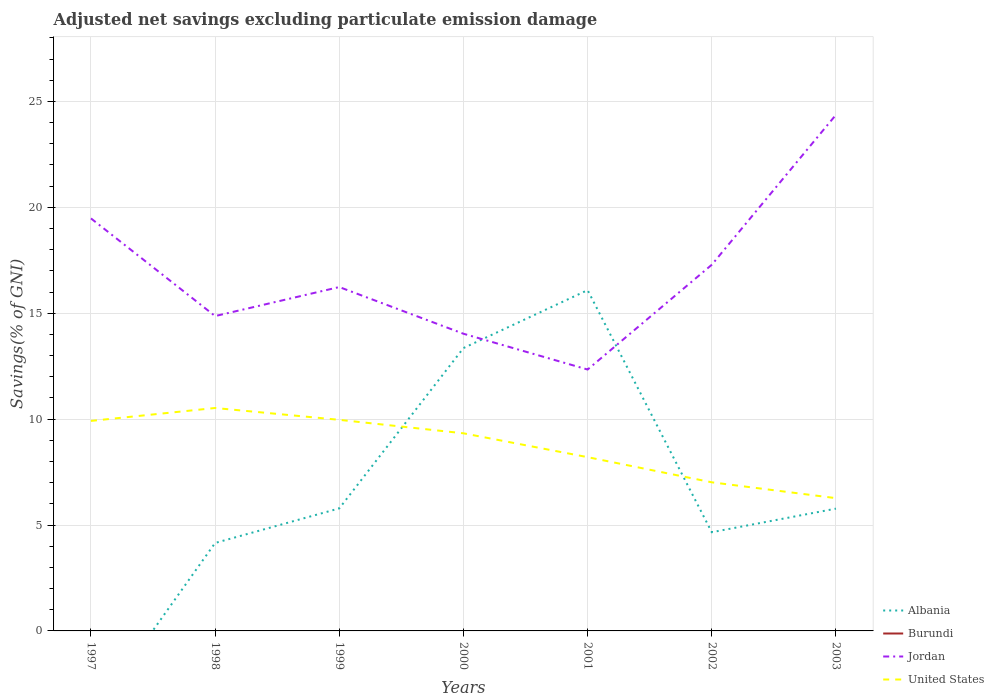Does the line corresponding to Albania intersect with the line corresponding to Burundi?
Your answer should be very brief. No. Is the number of lines equal to the number of legend labels?
Ensure brevity in your answer.  No. Across all years, what is the maximum adjusted net savings in Jordan?
Your response must be concise. 12.34. What is the total adjusted net savings in Jordan in the graph?
Offer a terse response. 2.52. What is the difference between the highest and the second highest adjusted net savings in United States?
Offer a very short reply. 4.26. What is the difference between the highest and the lowest adjusted net savings in Jordan?
Offer a very short reply. 3. How many years are there in the graph?
Keep it short and to the point. 7. What is the difference between two consecutive major ticks on the Y-axis?
Make the answer very short. 5. Where does the legend appear in the graph?
Make the answer very short. Bottom right. How many legend labels are there?
Provide a succinct answer. 4. What is the title of the graph?
Your answer should be very brief. Adjusted net savings excluding particulate emission damage. What is the label or title of the Y-axis?
Your answer should be very brief. Savings(% of GNI). What is the Savings(% of GNI) in Albania in 1997?
Offer a very short reply. 0. What is the Savings(% of GNI) of Burundi in 1997?
Give a very brief answer. 0. What is the Savings(% of GNI) in Jordan in 1997?
Make the answer very short. 19.48. What is the Savings(% of GNI) in United States in 1997?
Your answer should be compact. 9.92. What is the Savings(% of GNI) of Albania in 1998?
Your response must be concise. 4.15. What is the Savings(% of GNI) of Jordan in 1998?
Ensure brevity in your answer.  14.86. What is the Savings(% of GNI) in United States in 1998?
Make the answer very short. 10.53. What is the Savings(% of GNI) in Albania in 1999?
Your answer should be very brief. 5.79. What is the Savings(% of GNI) in Jordan in 1999?
Provide a succinct answer. 16.24. What is the Savings(% of GNI) in United States in 1999?
Offer a very short reply. 9.97. What is the Savings(% of GNI) in Albania in 2000?
Provide a short and direct response. 13.35. What is the Savings(% of GNI) of Jordan in 2000?
Give a very brief answer. 14.03. What is the Savings(% of GNI) in United States in 2000?
Your response must be concise. 9.33. What is the Savings(% of GNI) in Albania in 2001?
Offer a very short reply. 16.09. What is the Savings(% of GNI) in Burundi in 2001?
Offer a terse response. 0. What is the Savings(% of GNI) in Jordan in 2001?
Provide a short and direct response. 12.34. What is the Savings(% of GNI) of United States in 2001?
Make the answer very short. 8.2. What is the Savings(% of GNI) in Albania in 2002?
Your response must be concise. 4.66. What is the Savings(% of GNI) in Jordan in 2002?
Your answer should be compact. 17.29. What is the Savings(% of GNI) of United States in 2002?
Keep it short and to the point. 7.02. What is the Savings(% of GNI) in Albania in 2003?
Provide a short and direct response. 5.77. What is the Savings(% of GNI) of Burundi in 2003?
Ensure brevity in your answer.  0. What is the Savings(% of GNI) in Jordan in 2003?
Your answer should be very brief. 24.37. What is the Savings(% of GNI) of United States in 2003?
Your answer should be compact. 6.27. Across all years, what is the maximum Savings(% of GNI) in Albania?
Ensure brevity in your answer.  16.09. Across all years, what is the maximum Savings(% of GNI) in Jordan?
Offer a very short reply. 24.37. Across all years, what is the maximum Savings(% of GNI) in United States?
Ensure brevity in your answer.  10.53. Across all years, what is the minimum Savings(% of GNI) of Jordan?
Your answer should be compact. 12.34. Across all years, what is the minimum Savings(% of GNI) of United States?
Your answer should be compact. 6.27. What is the total Savings(% of GNI) of Albania in the graph?
Give a very brief answer. 49.82. What is the total Savings(% of GNI) in Burundi in the graph?
Provide a short and direct response. 0. What is the total Savings(% of GNI) of Jordan in the graph?
Provide a succinct answer. 118.6. What is the total Savings(% of GNI) of United States in the graph?
Make the answer very short. 61.23. What is the difference between the Savings(% of GNI) of Jordan in 1997 and that in 1998?
Give a very brief answer. 4.61. What is the difference between the Savings(% of GNI) in United States in 1997 and that in 1998?
Give a very brief answer. -0.61. What is the difference between the Savings(% of GNI) in Jordan in 1997 and that in 1999?
Offer a very short reply. 3.24. What is the difference between the Savings(% of GNI) in United States in 1997 and that in 1999?
Provide a succinct answer. -0.05. What is the difference between the Savings(% of GNI) of Jordan in 1997 and that in 2000?
Your response must be concise. 5.44. What is the difference between the Savings(% of GNI) of United States in 1997 and that in 2000?
Offer a very short reply. 0.59. What is the difference between the Savings(% of GNI) of Jordan in 1997 and that in 2001?
Keep it short and to the point. 7.13. What is the difference between the Savings(% of GNI) in United States in 1997 and that in 2001?
Your response must be concise. 1.71. What is the difference between the Savings(% of GNI) in Jordan in 1997 and that in 2002?
Offer a terse response. 2.19. What is the difference between the Savings(% of GNI) of United States in 1997 and that in 2002?
Provide a short and direct response. 2.9. What is the difference between the Savings(% of GNI) of Jordan in 1997 and that in 2003?
Your answer should be compact. -4.89. What is the difference between the Savings(% of GNI) of United States in 1997 and that in 2003?
Make the answer very short. 3.65. What is the difference between the Savings(% of GNI) in Albania in 1998 and that in 1999?
Your answer should be very brief. -1.63. What is the difference between the Savings(% of GNI) in Jordan in 1998 and that in 1999?
Provide a short and direct response. -1.37. What is the difference between the Savings(% of GNI) in United States in 1998 and that in 1999?
Make the answer very short. 0.56. What is the difference between the Savings(% of GNI) in Albania in 1998 and that in 2000?
Your response must be concise. -9.2. What is the difference between the Savings(% of GNI) in Jordan in 1998 and that in 2000?
Give a very brief answer. 0.83. What is the difference between the Savings(% of GNI) of United States in 1998 and that in 2000?
Your answer should be very brief. 1.19. What is the difference between the Savings(% of GNI) in Albania in 1998 and that in 2001?
Provide a short and direct response. -11.94. What is the difference between the Savings(% of GNI) in Jordan in 1998 and that in 2001?
Provide a succinct answer. 2.52. What is the difference between the Savings(% of GNI) in United States in 1998 and that in 2001?
Make the answer very short. 2.32. What is the difference between the Savings(% of GNI) of Albania in 1998 and that in 2002?
Ensure brevity in your answer.  -0.51. What is the difference between the Savings(% of GNI) of Jordan in 1998 and that in 2002?
Your answer should be compact. -2.42. What is the difference between the Savings(% of GNI) in United States in 1998 and that in 2002?
Give a very brief answer. 3.51. What is the difference between the Savings(% of GNI) of Albania in 1998 and that in 2003?
Offer a very short reply. -1.62. What is the difference between the Savings(% of GNI) of Jordan in 1998 and that in 2003?
Keep it short and to the point. -9.5. What is the difference between the Savings(% of GNI) of United States in 1998 and that in 2003?
Make the answer very short. 4.26. What is the difference between the Savings(% of GNI) of Albania in 1999 and that in 2000?
Offer a very short reply. -7.57. What is the difference between the Savings(% of GNI) in Jordan in 1999 and that in 2000?
Ensure brevity in your answer.  2.2. What is the difference between the Savings(% of GNI) in United States in 1999 and that in 2000?
Your answer should be compact. 0.64. What is the difference between the Savings(% of GNI) of Albania in 1999 and that in 2001?
Make the answer very short. -10.3. What is the difference between the Savings(% of GNI) of Jordan in 1999 and that in 2001?
Offer a very short reply. 3.89. What is the difference between the Savings(% of GNI) of United States in 1999 and that in 2001?
Make the answer very short. 1.76. What is the difference between the Savings(% of GNI) of Albania in 1999 and that in 2002?
Keep it short and to the point. 1.12. What is the difference between the Savings(% of GNI) of Jordan in 1999 and that in 2002?
Offer a very short reply. -1.05. What is the difference between the Savings(% of GNI) of United States in 1999 and that in 2002?
Your answer should be very brief. 2.95. What is the difference between the Savings(% of GNI) of Albania in 1999 and that in 2003?
Ensure brevity in your answer.  0.01. What is the difference between the Savings(% of GNI) in Jordan in 1999 and that in 2003?
Offer a very short reply. -8.13. What is the difference between the Savings(% of GNI) in United States in 1999 and that in 2003?
Keep it short and to the point. 3.7. What is the difference between the Savings(% of GNI) of Albania in 2000 and that in 2001?
Give a very brief answer. -2.73. What is the difference between the Savings(% of GNI) of Jordan in 2000 and that in 2001?
Your response must be concise. 1.69. What is the difference between the Savings(% of GNI) in United States in 2000 and that in 2001?
Offer a very short reply. 1.13. What is the difference between the Savings(% of GNI) of Albania in 2000 and that in 2002?
Your answer should be very brief. 8.69. What is the difference between the Savings(% of GNI) in Jordan in 2000 and that in 2002?
Your response must be concise. -3.26. What is the difference between the Savings(% of GNI) in United States in 2000 and that in 2002?
Your response must be concise. 2.31. What is the difference between the Savings(% of GNI) of Albania in 2000 and that in 2003?
Offer a terse response. 7.58. What is the difference between the Savings(% of GNI) in Jordan in 2000 and that in 2003?
Provide a succinct answer. -10.34. What is the difference between the Savings(% of GNI) in United States in 2000 and that in 2003?
Your response must be concise. 3.06. What is the difference between the Savings(% of GNI) in Albania in 2001 and that in 2002?
Your answer should be very brief. 11.43. What is the difference between the Savings(% of GNI) of Jordan in 2001 and that in 2002?
Provide a short and direct response. -4.95. What is the difference between the Savings(% of GNI) in United States in 2001 and that in 2002?
Give a very brief answer. 1.19. What is the difference between the Savings(% of GNI) of Albania in 2001 and that in 2003?
Your answer should be compact. 10.32. What is the difference between the Savings(% of GNI) of Jordan in 2001 and that in 2003?
Offer a terse response. -12.02. What is the difference between the Savings(% of GNI) in United States in 2001 and that in 2003?
Offer a very short reply. 1.94. What is the difference between the Savings(% of GNI) of Albania in 2002 and that in 2003?
Make the answer very short. -1.11. What is the difference between the Savings(% of GNI) of Jordan in 2002 and that in 2003?
Give a very brief answer. -7.08. What is the difference between the Savings(% of GNI) of United States in 2002 and that in 2003?
Give a very brief answer. 0.75. What is the difference between the Savings(% of GNI) in Jordan in 1997 and the Savings(% of GNI) in United States in 1998?
Your answer should be compact. 8.95. What is the difference between the Savings(% of GNI) in Jordan in 1997 and the Savings(% of GNI) in United States in 1999?
Provide a short and direct response. 9.51. What is the difference between the Savings(% of GNI) in Jordan in 1997 and the Savings(% of GNI) in United States in 2000?
Give a very brief answer. 10.15. What is the difference between the Savings(% of GNI) of Jordan in 1997 and the Savings(% of GNI) of United States in 2001?
Offer a very short reply. 11.27. What is the difference between the Savings(% of GNI) of Jordan in 1997 and the Savings(% of GNI) of United States in 2002?
Offer a very short reply. 12.46. What is the difference between the Savings(% of GNI) in Jordan in 1997 and the Savings(% of GNI) in United States in 2003?
Offer a terse response. 13.21. What is the difference between the Savings(% of GNI) in Albania in 1998 and the Savings(% of GNI) in Jordan in 1999?
Your answer should be compact. -12.08. What is the difference between the Savings(% of GNI) of Albania in 1998 and the Savings(% of GNI) of United States in 1999?
Your answer should be compact. -5.81. What is the difference between the Savings(% of GNI) in Jordan in 1998 and the Savings(% of GNI) in United States in 1999?
Provide a succinct answer. 4.9. What is the difference between the Savings(% of GNI) in Albania in 1998 and the Savings(% of GNI) in Jordan in 2000?
Your answer should be very brief. -9.88. What is the difference between the Savings(% of GNI) in Albania in 1998 and the Savings(% of GNI) in United States in 2000?
Provide a short and direct response. -5.18. What is the difference between the Savings(% of GNI) of Jordan in 1998 and the Savings(% of GNI) of United States in 2000?
Offer a terse response. 5.53. What is the difference between the Savings(% of GNI) of Albania in 1998 and the Savings(% of GNI) of Jordan in 2001?
Keep it short and to the point. -8.19. What is the difference between the Savings(% of GNI) of Albania in 1998 and the Savings(% of GNI) of United States in 2001?
Make the answer very short. -4.05. What is the difference between the Savings(% of GNI) of Jordan in 1998 and the Savings(% of GNI) of United States in 2001?
Your answer should be very brief. 6.66. What is the difference between the Savings(% of GNI) in Albania in 1998 and the Savings(% of GNI) in Jordan in 2002?
Make the answer very short. -13.13. What is the difference between the Savings(% of GNI) of Albania in 1998 and the Savings(% of GNI) of United States in 2002?
Keep it short and to the point. -2.86. What is the difference between the Savings(% of GNI) in Jordan in 1998 and the Savings(% of GNI) in United States in 2002?
Your answer should be very brief. 7.85. What is the difference between the Savings(% of GNI) of Albania in 1998 and the Savings(% of GNI) of Jordan in 2003?
Ensure brevity in your answer.  -20.21. What is the difference between the Savings(% of GNI) in Albania in 1998 and the Savings(% of GNI) in United States in 2003?
Offer a terse response. -2.12. What is the difference between the Savings(% of GNI) of Jordan in 1998 and the Savings(% of GNI) of United States in 2003?
Make the answer very short. 8.6. What is the difference between the Savings(% of GNI) in Albania in 1999 and the Savings(% of GNI) in Jordan in 2000?
Offer a very short reply. -8.25. What is the difference between the Savings(% of GNI) of Albania in 1999 and the Savings(% of GNI) of United States in 2000?
Offer a terse response. -3.55. What is the difference between the Savings(% of GNI) in Jordan in 1999 and the Savings(% of GNI) in United States in 2000?
Your answer should be compact. 6.9. What is the difference between the Savings(% of GNI) of Albania in 1999 and the Savings(% of GNI) of Jordan in 2001?
Your answer should be very brief. -6.56. What is the difference between the Savings(% of GNI) of Albania in 1999 and the Savings(% of GNI) of United States in 2001?
Ensure brevity in your answer.  -2.42. What is the difference between the Savings(% of GNI) of Jordan in 1999 and the Savings(% of GNI) of United States in 2001?
Make the answer very short. 8.03. What is the difference between the Savings(% of GNI) of Albania in 1999 and the Savings(% of GNI) of Jordan in 2002?
Provide a succinct answer. -11.5. What is the difference between the Savings(% of GNI) of Albania in 1999 and the Savings(% of GNI) of United States in 2002?
Keep it short and to the point. -1.23. What is the difference between the Savings(% of GNI) in Jordan in 1999 and the Savings(% of GNI) in United States in 2002?
Make the answer very short. 9.22. What is the difference between the Savings(% of GNI) of Albania in 1999 and the Savings(% of GNI) of Jordan in 2003?
Give a very brief answer. -18.58. What is the difference between the Savings(% of GNI) in Albania in 1999 and the Savings(% of GNI) in United States in 2003?
Offer a very short reply. -0.48. What is the difference between the Savings(% of GNI) in Jordan in 1999 and the Savings(% of GNI) in United States in 2003?
Your answer should be very brief. 9.97. What is the difference between the Savings(% of GNI) of Albania in 2000 and the Savings(% of GNI) of Jordan in 2001?
Make the answer very short. 1.01. What is the difference between the Savings(% of GNI) in Albania in 2000 and the Savings(% of GNI) in United States in 2001?
Provide a succinct answer. 5.15. What is the difference between the Savings(% of GNI) in Jordan in 2000 and the Savings(% of GNI) in United States in 2001?
Your answer should be compact. 5.83. What is the difference between the Savings(% of GNI) in Albania in 2000 and the Savings(% of GNI) in Jordan in 2002?
Provide a short and direct response. -3.93. What is the difference between the Savings(% of GNI) in Albania in 2000 and the Savings(% of GNI) in United States in 2002?
Offer a terse response. 6.34. What is the difference between the Savings(% of GNI) of Jordan in 2000 and the Savings(% of GNI) of United States in 2002?
Provide a short and direct response. 7.01. What is the difference between the Savings(% of GNI) in Albania in 2000 and the Savings(% of GNI) in Jordan in 2003?
Keep it short and to the point. -11.01. What is the difference between the Savings(% of GNI) in Albania in 2000 and the Savings(% of GNI) in United States in 2003?
Your answer should be compact. 7.09. What is the difference between the Savings(% of GNI) in Jordan in 2000 and the Savings(% of GNI) in United States in 2003?
Offer a terse response. 7.76. What is the difference between the Savings(% of GNI) of Albania in 2001 and the Savings(% of GNI) of Jordan in 2002?
Ensure brevity in your answer.  -1.2. What is the difference between the Savings(% of GNI) in Albania in 2001 and the Savings(% of GNI) in United States in 2002?
Your answer should be very brief. 9.07. What is the difference between the Savings(% of GNI) in Jordan in 2001 and the Savings(% of GNI) in United States in 2002?
Offer a very short reply. 5.32. What is the difference between the Savings(% of GNI) in Albania in 2001 and the Savings(% of GNI) in Jordan in 2003?
Keep it short and to the point. -8.28. What is the difference between the Savings(% of GNI) of Albania in 2001 and the Savings(% of GNI) of United States in 2003?
Your answer should be compact. 9.82. What is the difference between the Savings(% of GNI) of Jordan in 2001 and the Savings(% of GNI) of United States in 2003?
Provide a short and direct response. 6.07. What is the difference between the Savings(% of GNI) in Albania in 2002 and the Savings(% of GNI) in Jordan in 2003?
Make the answer very short. -19.71. What is the difference between the Savings(% of GNI) of Albania in 2002 and the Savings(% of GNI) of United States in 2003?
Your response must be concise. -1.61. What is the difference between the Savings(% of GNI) in Jordan in 2002 and the Savings(% of GNI) in United States in 2003?
Your answer should be compact. 11.02. What is the average Savings(% of GNI) in Albania per year?
Keep it short and to the point. 7.12. What is the average Savings(% of GNI) of Jordan per year?
Your answer should be very brief. 16.94. What is the average Savings(% of GNI) in United States per year?
Provide a succinct answer. 8.75. In the year 1997, what is the difference between the Savings(% of GNI) of Jordan and Savings(% of GNI) of United States?
Give a very brief answer. 9.56. In the year 1998, what is the difference between the Savings(% of GNI) of Albania and Savings(% of GNI) of Jordan?
Make the answer very short. -10.71. In the year 1998, what is the difference between the Savings(% of GNI) in Albania and Savings(% of GNI) in United States?
Your answer should be very brief. -6.37. In the year 1998, what is the difference between the Savings(% of GNI) of Jordan and Savings(% of GNI) of United States?
Make the answer very short. 4.34. In the year 1999, what is the difference between the Savings(% of GNI) in Albania and Savings(% of GNI) in Jordan?
Offer a terse response. -10.45. In the year 1999, what is the difference between the Savings(% of GNI) in Albania and Savings(% of GNI) in United States?
Offer a very short reply. -4.18. In the year 1999, what is the difference between the Savings(% of GNI) in Jordan and Savings(% of GNI) in United States?
Ensure brevity in your answer.  6.27. In the year 2000, what is the difference between the Savings(% of GNI) of Albania and Savings(% of GNI) of Jordan?
Offer a terse response. -0.68. In the year 2000, what is the difference between the Savings(% of GNI) of Albania and Savings(% of GNI) of United States?
Keep it short and to the point. 4.02. In the year 2000, what is the difference between the Savings(% of GNI) of Jordan and Savings(% of GNI) of United States?
Ensure brevity in your answer.  4.7. In the year 2001, what is the difference between the Savings(% of GNI) in Albania and Savings(% of GNI) in Jordan?
Make the answer very short. 3.75. In the year 2001, what is the difference between the Savings(% of GNI) in Albania and Savings(% of GNI) in United States?
Offer a very short reply. 7.88. In the year 2001, what is the difference between the Savings(% of GNI) in Jordan and Savings(% of GNI) in United States?
Offer a terse response. 4.14. In the year 2002, what is the difference between the Savings(% of GNI) in Albania and Savings(% of GNI) in Jordan?
Your answer should be very brief. -12.63. In the year 2002, what is the difference between the Savings(% of GNI) of Albania and Savings(% of GNI) of United States?
Provide a short and direct response. -2.36. In the year 2002, what is the difference between the Savings(% of GNI) in Jordan and Savings(% of GNI) in United States?
Provide a short and direct response. 10.27. In the year 2003, what is the difference between the Savings(% of GNI) of Albania and Savings(% of GNI) of Jordan?
Give a very brief answer. -18.59. In the year 2003, what is the difference between the Savings(% of GNI) of Albania and Savings(% of GNI) of United States?
Provide a succinct answer. -0.5. In the year 2003, what is the difference between the Savings(% of GNI) in Jordan and Savings(% of GNI) in United States?
Provide a short and direct response. 18.1. What is the ratio of the Savings(% of GNI) in Jordan in 1997 to that in 1998?
Your answer should be very brief. 1.31. What is the ratio of the Savings(% of GNI) in United States in 1997 to that in 1998?
Provide a short and direct response. 0.94. What is the ratio of the Savings(% of GNI) in Jordan in 1997 to that in 1999?
Ensure brevity in your answer.  1.2. What is the ratio of the Savings(% of GNI) in United States in 1997 to that in 1999?
Offer a terse response. 0.99. What is the ratio of the Savings(% of GNI) in Jordan in 1997 to that in 2000?
Your answer should be very brief. 1.39. What is the ratio of the Savings(% of GNI) of United States in 1997 to that in 2000?
Your answer should be very brief. 1.06. What is the ratio of the Savings(% of GNI) in Jordan in 1997 to that in 2001?
Offer a terse response. 1.58. What is the ratio of the Savings(% of GNI) in United States in 1997 to that in 2001?
Your response must be concise. 1.21. What is the ratio of the Savings(% of GNI) in Jordan in 1997 to that in 2002?
Ensure brevity in your answer.  1.13. What is the ratio of the Savings(% of GNI) in United States in 1997 to that in 2002?
Provide a short and direct response. 1.41. What is the ratio of the Savings(% of GNI) in Jordan in 1997 to that in 2003?
Keep it short and to the point. 0.8. What is the ratio of the Savings(% of GNI) of United States in 1997 to that in 2003?
Provide a succinct answer. 1.58. What is the ratio of the Savings(% of GNI) of Albania in 1998 to that in 1999?
Provide a succinct answer. 0.72. What is the ratio of the Savings(% of GNI) in Jordan in 1998 to that in 1999?
Your answer should be very brief. 0.92. What is the ratio of the Savings(% of GNI) of United States in 1998 to that in 1999?
Offer a terse response. 1.06. What is the ratio of the Savings(% of GNI) in Albania in 1998 to that in 2000?
Your response must be concise. 0.31. What is the ratio of the Savings(% of GNI) in Jordan in 1998 to that in 2000?
Ensure brevity in your answer.  1.06. What is the ratio of the Savings(% of GNI) of United States in 1998 to that in 2000?
Your answer should be compact. 1.13. What is the ratio of the Savings(% of GNI) in Albania in 1998 to that in 2001?
Provide a short and direct response. 0.26. What is the ratio of the Savings(% of GNI) in Jordan in 1998 to that in 2001?
Ensure brevity in your answer.  1.2. What is the ratio of the Savings(% of GNI) in United States in 1998 to that in 2001?
Offer a terse response. 1.28. What is the ratio of the Savings(% of GNI) of Albania in 1998 to that in 2002?
Offer a terse response. 0.89. What is the ratio of the Savings(% of GNI) of Jordan in 1998 to that in 2002?
Make the answer very short. 0.86. What is the ratio of the Savings(% of GNI) in Albania in 1998 to that in 2003?
Provide a succinct answer. 0.72. What is the ratio of the Savings(% of GNI) of Jordan in 1998 to that in 2003?
Make the answer very short. 0.61. What is the ratio of the Savings(% of GNI) of United States in 1998 to that in 2003?
Provide a short and direct response. 1.68. What is the ratio of the Savings(% of GNI) in Albania in 1999 to that in 2000?
Keep it short and to the point. 0.43. What is the ratio of the Savings(% of GNI) in Jordan in 1999 to that in 2000?
Your answer should be compact. 1.16. What is the ratio of the Savings(% of GNI) of United States in 1999 to that in 2000?
Your response must be concise. 1.07. What is the ratio of the Savings(% of GNI) of Albania in 1999 to that in 2001?
Offer a terse response. 0.36. What is the ratio of the Savings(% of GNI) of Jordan in 1999 to that in 2001?
Your answer should be very brief. 1.32. What is the ratio of the Savings(% of GNI) in United States in 1999 to that in 2001?
Ensure brevity in your answer.  1.21. What is the ratio of the Savings(% of GNI) in Albania in 1999 to that in 2002?
Offer a terse response. 1.24. What is the ratio of the Savings(% of GNI) in Jordan in 1999 to that in 2002?
Your answer should be compact. 0.94. What is the ratio of the Savings(% of GNI) of United States in 1999 to that in 2002?
Offer a terse response. 1.42. What is the ratio of the Savings(% of GNI) of Jordan in 1999 to that in 2003?
Keep it short and to the point. 0.67. What is the ratio of the Savings(% of GNI) of United States in 1999 to that in 2003?
Your answer should be very brief. 1.59. What is the ratio of the Savings(% of GNI) of Albania in 2000 to that in 2001?
Provide a short and direct response. 0.83. What is the ratio of the Savings(% of GNI) of Jordan in 2000 to that in 2001?
Give a very brief answer. 1.14. What is the ratio of the Savings(% of GNI) of United States in 2000 to that in 2001?
Provide a succinct answer. 1.14. What is the ratio of the Savings(% of GNI) of Albania in 2000 to that in 2002?
Your response must be concise. 2.87. What is the ratio of the Savings(% of GNI) in Jordan in 2000 to that in 2002?
Give a very brief answer. 0.81. What is the ratio of the Savings(% of GNI) of United States in 2000 to that in 2002?
Provide a short and direct response. 1.33. What is the ratio of the Savings(% of GNI) of Albania in 2000 to that in 2003?
Make the answer very short. 2.31. What is the ratio of the Savings(% of GNI) in Jordan in 2000 to that in 2003?
Give a very brief answer. 0.58. What is the ratio of the Savings(% of GNI) of United States in 2000 to that in 2003?
Offer a terse response. 1.49. What is the ratio of the Savings(% of GNI) in Albania in 2001 to that in 2002?
Offer a terse response. 3.45. What is the ratio of the Savings(% of GNI) in Jordan in 2001 to that in 2002?
Provide a succinct answer. 0.71. What is the ratio of the Savings(% of GNI) in United States in 2001 to that in 2002?
Make the answer very short. 1.17. What is the ratio of the Savings(% of GNI) in Albania in 2001 to that in 2003?
Your response must be concise. 2.79. What is the ratio of the Savings(% of GNI) in Jordan in 2001 to that in 2003?
Offer a very short reply. 0.51. What is the ratio of the Savings(% of GNI) in United States in 2001 to that in 2003?
Offer a very short reply. 1.31. What is the ratio of the Savings(% of GNI) of Albania in 2002 to that in 2003?
Offer a very short reply. 0.81. What is the ratio of the Savings(% of GNI) of Jordan in 2002 to that in 2003?
Your answer should be very brief. 0.71. What is the ratio of the Savings(% of GNI) in United States in 2002 to that in 2003?
Make the answer very short. 1.12. What is the difference between the highest and the second highest Savings(% of GNI) of Albania?
Keep it short and to the point. 2.73. What is the difference between the highest and the second highest Savings(% of GNI) in Jordan?
Provide a short and direct response. 4.89. What is the difference between the highest and the second highest Savings(% of GNI) in United States?
Offer a very short reply. 0.56. What is the difference between the highest and the lowest Savings(% of GNI) of Albania?
Your answer should be very brief. 16.09. What is the difference between the highest and the lowest Savings(% of GNI) in Jordan?
Provide a succinct answer. 12.02. What is the difference between the highest and the lowest Savings(% of GNI) of United States?
Your answer should be compact. 4.26. 